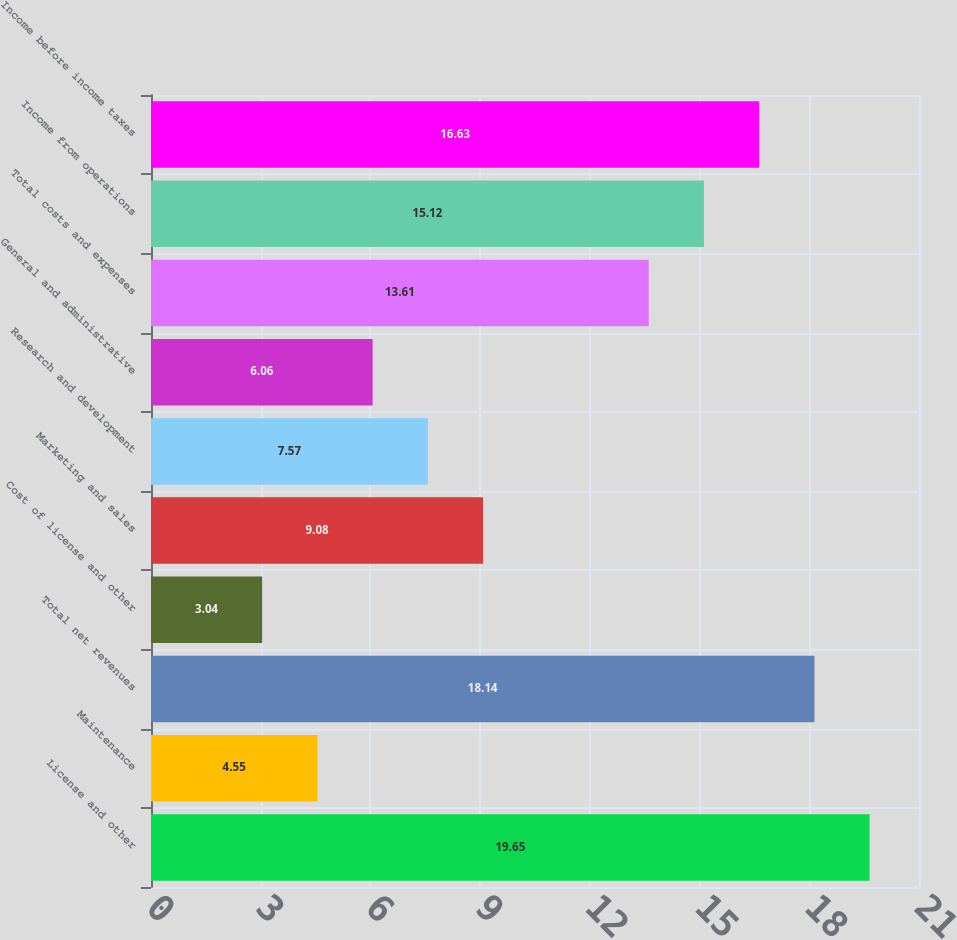Convert chart. <chart><loc_0><loc_0><loc_500><loc_500><bar_chart><fcel>License and other<fcel>Maintenance<fcel>Total net revenues<fcel>Cost of license and other<fcel>Marketing and sales<fcel>Research and development<fcel>General and administrative<fcel>Total costs and expenses<fcel>Income from operations<fcel>Income before income taxes<nl><fcel>19.65<fcel>4.55<fcel>18.14<fcel>3.04<fcel>9.08<fcel>7.57<fcel>6.06<fcel>13.61<fcel>15.12<fcel>16.63<nl></chart> 